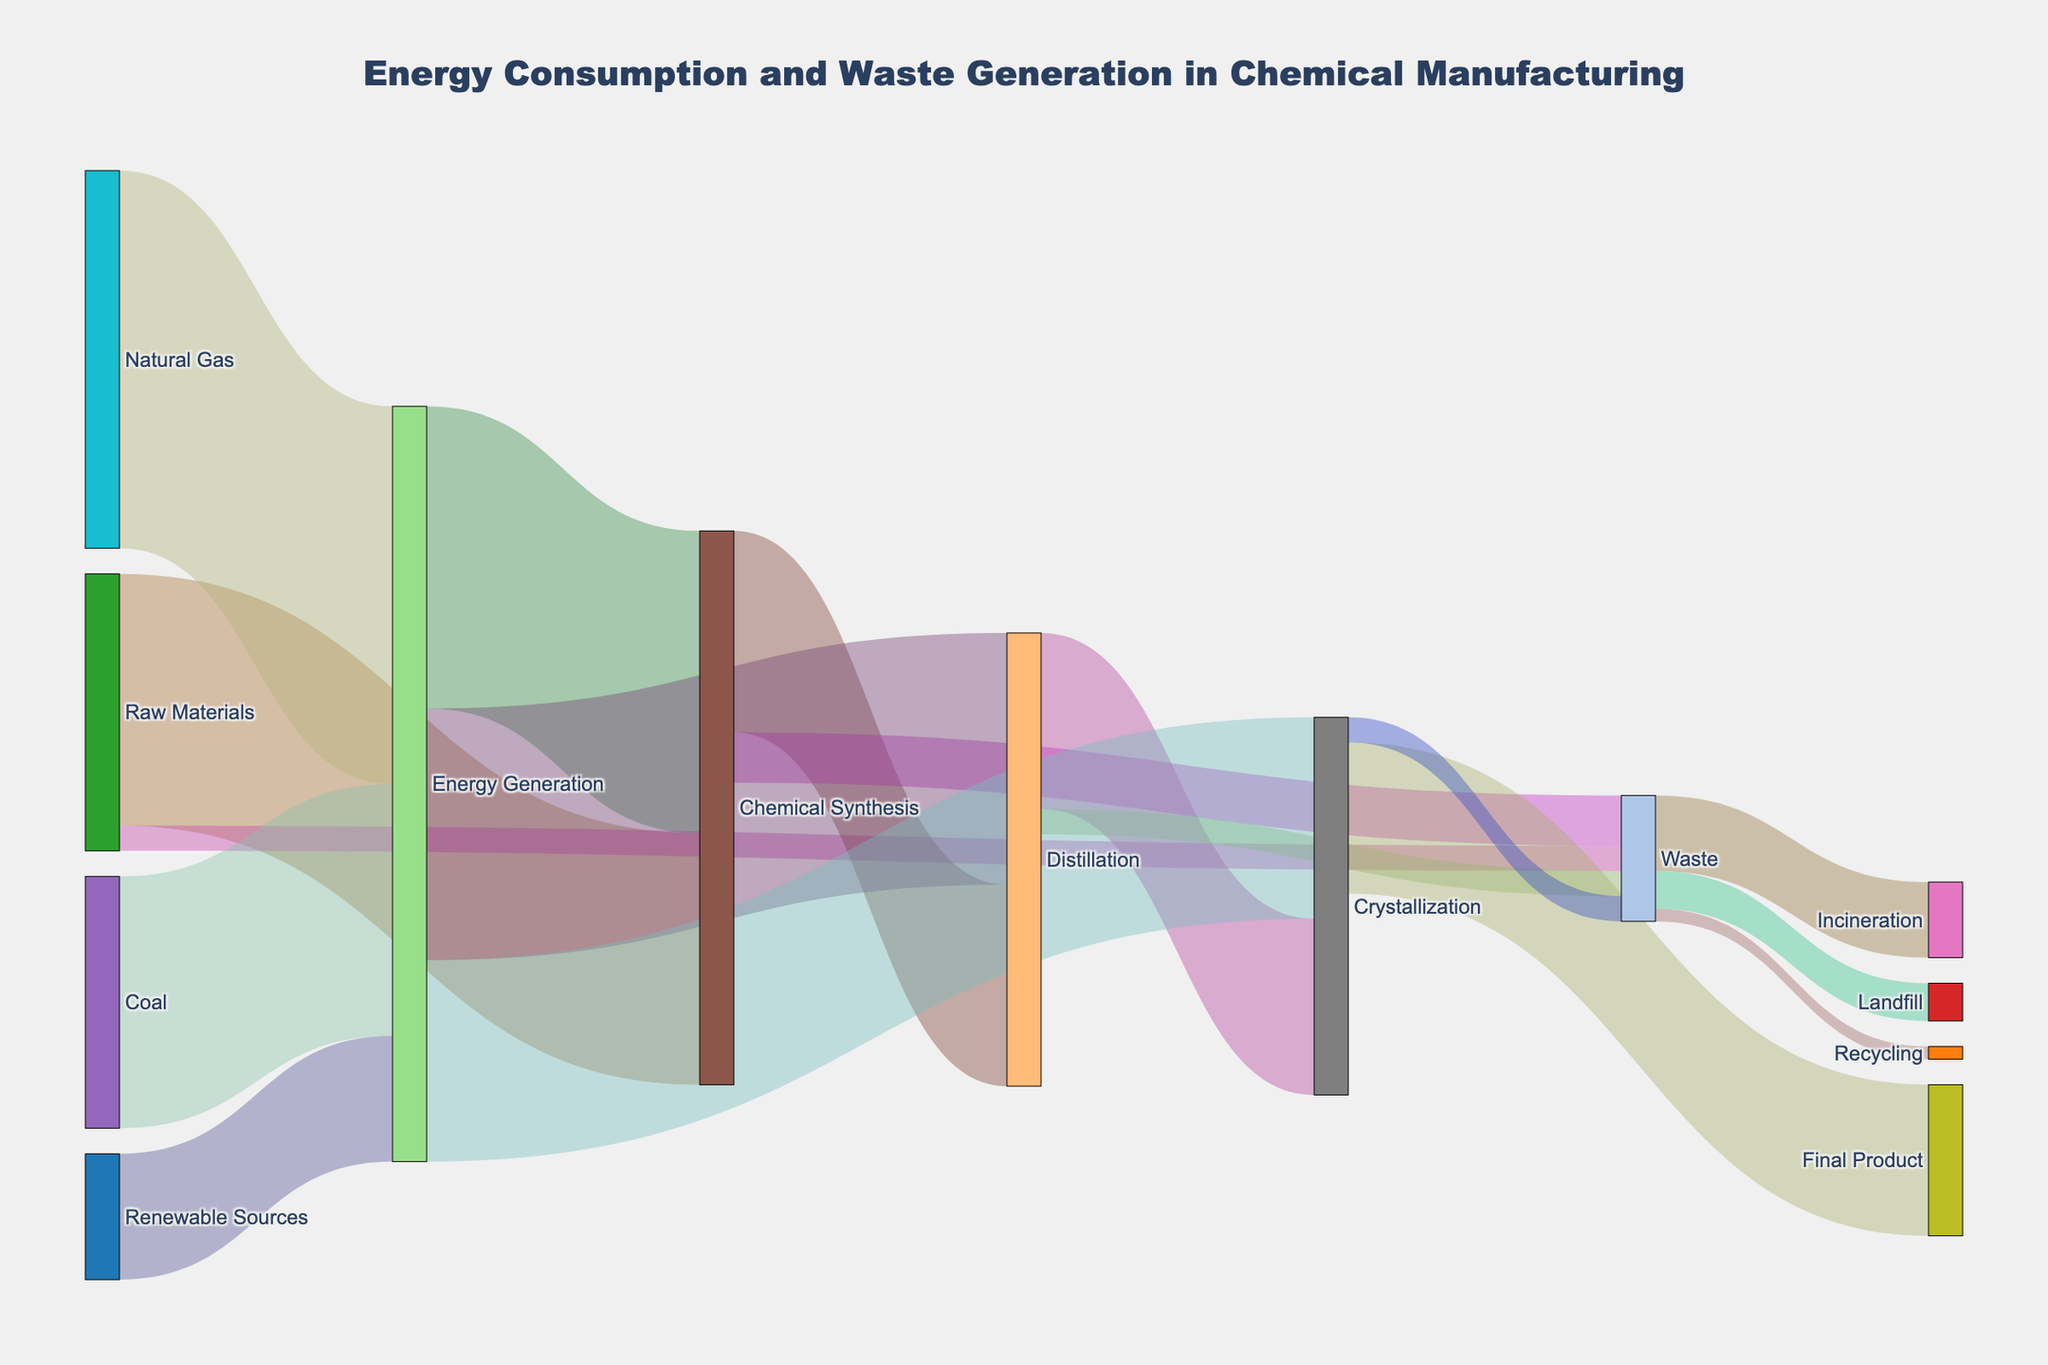what is the total flow from "Raw Materials" to "Waste"? To find the total flow from "Raw Materials" to "Waste", add all values where the source is "Raw Materials" and the target is "Waste". Here, "Raw Materials" to "Waste" has a value of 10.
Answer: 10 What percentage of "Chemical Synthesis" gets directed to "Distillation"? First, find the total outgoing flow from "Chemical Synthesis", which is 80 (to "Distillation") + 20 (to "Waste") = 100. Then, the flow to "Distillation" is 80. The percentage is (80/100) * 100 = 80%.
Answer: 80% How much of the energy generated comes from "Natural Gas"? The total energy generated is 150 (from "Natural Gas") + 100 (from "Coal") + 50 (from "Renewable Sources") = 300. The energy from "Natural Gas" is 150.
Answer: 50% Which energy source contributes the least to "Energy Generation"? Compare the values: "Natural Gas" (150), "Coal" (100), and "Renewable Sources" (50). "Renewable Sources" contribute the least.
Answer: Renewable Sources How much waste is directed to "Landfill"? Referring to the target with the label "Landfill", the value is listed as 15.
Answer: 15 What is the total flow from "Distillation"? Add all the outgoing flows from "Distillation": 70 (to "Crystallization") + 10 (to "Waste") = 80.
Answer: 80 What is the largest single flow in the diagram? The largest single flow can be identified by visually comparing the values of all flows. "Energy Generation" to "Chemical Synthesis" with a value of 120 is the largest.
Answer: 120 How much waste is generated in the entire process leading up to the "Final Product"? Add all the values targeting "Waste": 10 ("Raw Materials" to "Waste") + 20 ("Chemical Synthesis" to "Waste") + 10 ("Distillation" to "Waste") + 10 ("Crystallization" to "Waste") = 50.
Answer: 50 